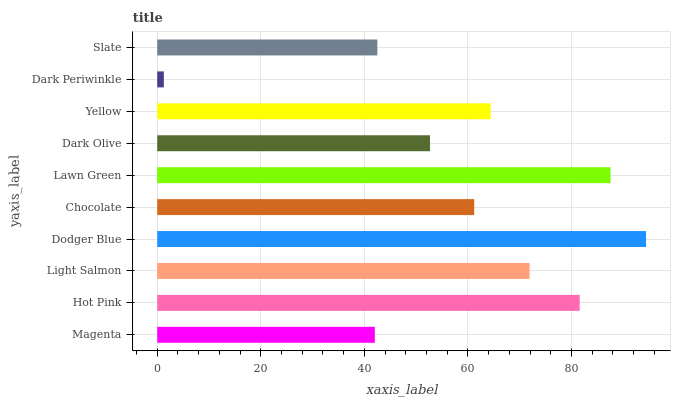Is Dark Periwinkle the minimum?
Answer yes or no. Yes. Is Dodger Blue the maximum?
Answer yes or no. Yes. Is Hot Pink the minimum?
Answer yes or no. No. Is Hot Pink the maximum?
Answer yes or no. No. Is Hot Pink greater than Magenta?
Answer yes or no. Yes. Is Magenta less than Hot Pink?
Answer yes or no. Yes. Is Magenta greater than Hot Pink?
Answer yes or no. No. Is Hot Pink less than Magenta?
Answer yes or no. No. Is Yellow the high median?
Answer yes or no. Yes. Is Chocolate the low median?
Answer yes or no. Yes. Is Hot Pink the high median?
Answer yes or no. No. Is Dark Periwinkle the low median?
Answer yes or no. No. 